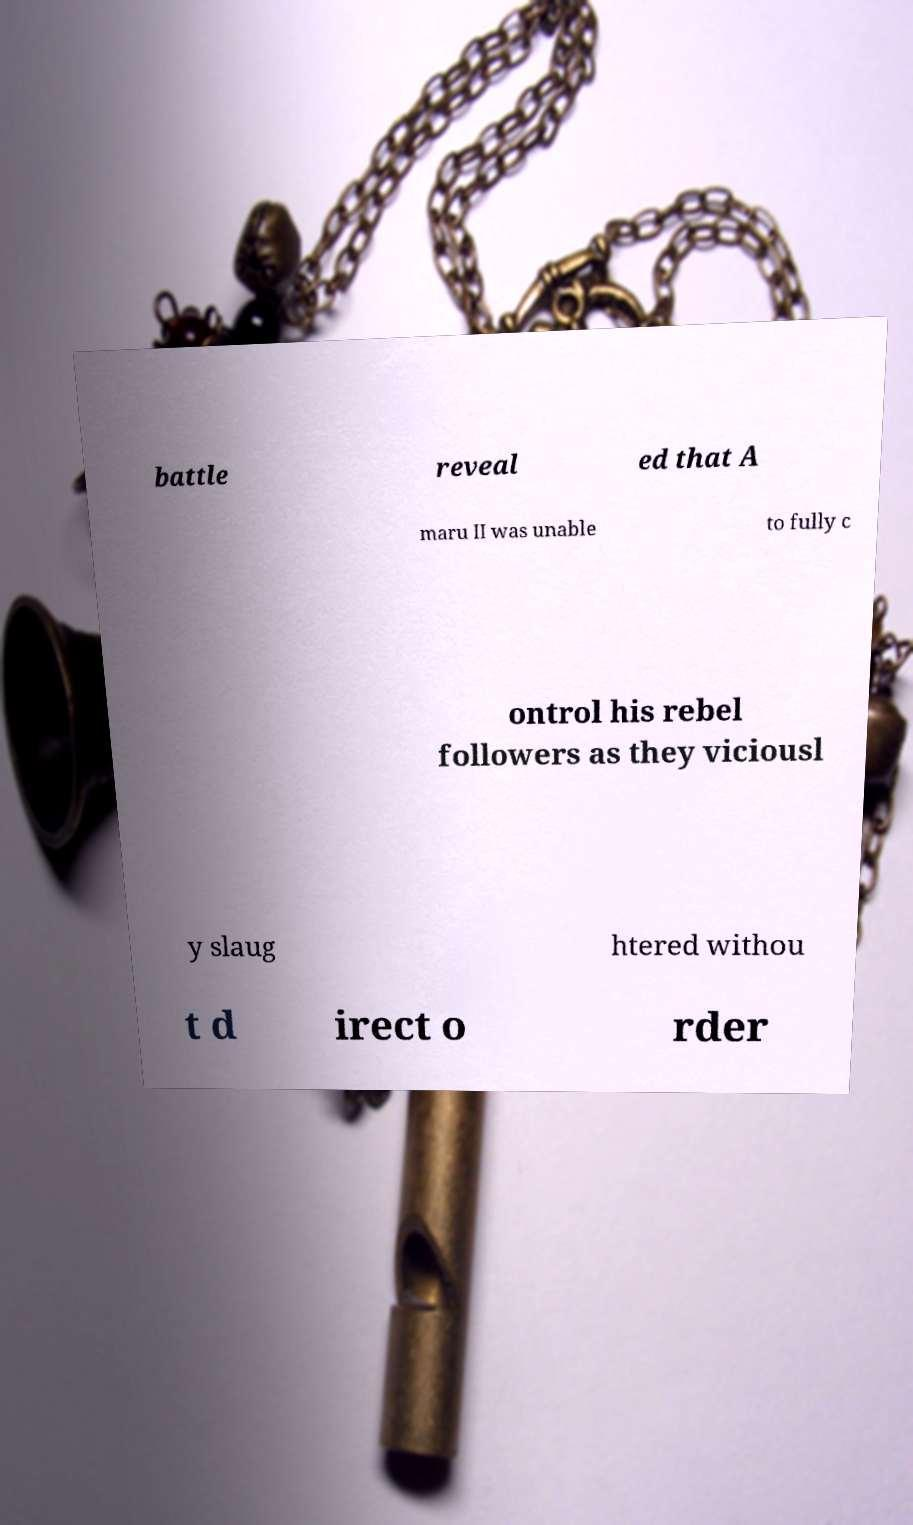Can you accurately transcribe the text from the provided image for me? battle reveal ed that A maru II was unable to fully c ontrol his rebel followers as they viciousl y slaug htered withou t d irect o rder 